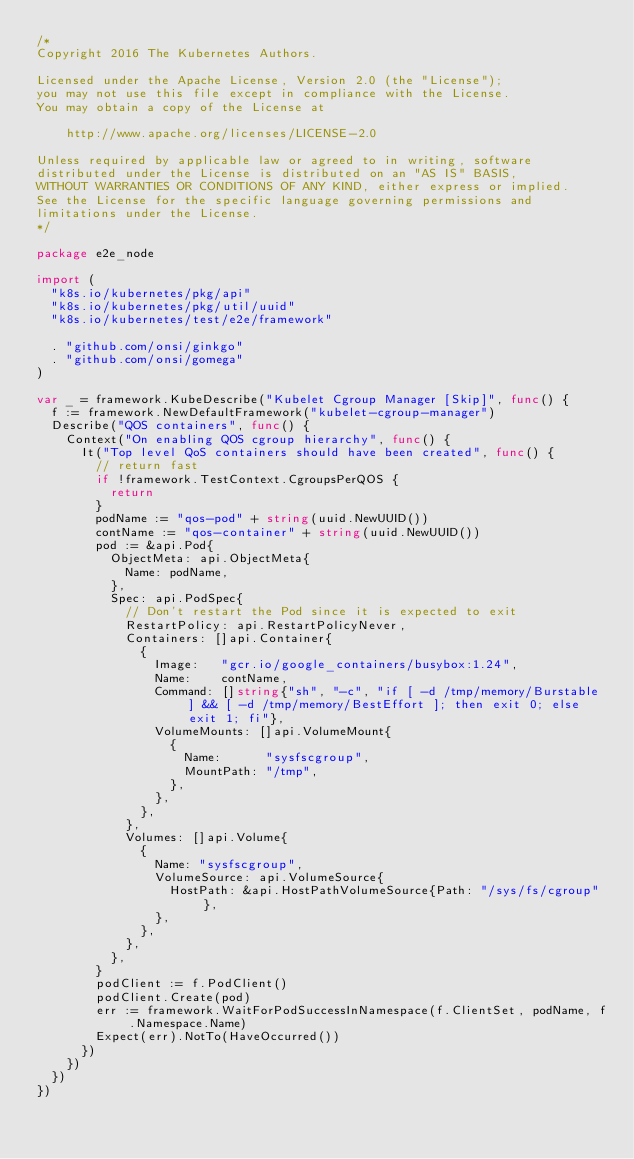<code> <loc_0><loc_0><loc_500><loc_500><_Go_>/*
Copyright 2016 The Kubernetes Authors.

Licensed under the Apache License, Version 2.0 (the "License");
you may not use this file except in compliance with the License.
You may obtain a copy of the License at

    http://www.apache.org/licenses/LICENSE-2.0

Unless required by applicable law or agreed to in writing, software
distributed under the License is distributed on an "AS IS" BASIS,
WITHOUT WARRANTIES OR CONDITIONS OF ANY KIND, either express or implied.
See the License for the specific language governing permissions and
limitations under the License.
*/

package e2e_node

import (
	"k8s.io/kubernetes/pkg/api"
	"k8s.io/kubernetes/pkg/util/uuid"
	"k8s.io/kubernetes/test/e2e/framework"

	. "github.com/onsi/ginkgo"
	. "github.com/onsi/gomega"
)

var _ = framework.KubeDescribe("Kubelet Cgroup Manager [Skip]", func() {
	f := framework.NewDefaultFramework("kubelet-cgroup-manager")
	Describe("QOS containers", func() {
		Context("On enabling QOS cgroup hierarchy", func() {
			It("Top level QoS containers should have been created", func() {
				// return fast
				if !framework.TestContext.CgroupsPerQOS {
					return
				}
				podName := "qos-pod" + string(uuid.NewUUID())
				contName := "qos-container" + string(uuid.NewUUID())
				pod := &api.Pod{
					ObjectMeta: api.ObjectMeta{
						Name: podName,
					},
					Spec: api.PodSpec{
						// Don't restart the Pod since it is expected to exit
						RestartPolicy: api.RestartPolicyNever,
						Containers: []api.Container{
							{
								Image:   "gcr.io/google_containers/busybox:1.24",
								Name:    contName,
								Command: []string{"sh", "-c", "if [ -d /tmp/memory/Burstable ] && [ -d /tmp/memory/BestEffort ]; then exit 0; else exit 1; fi"},
								VolumeMounts: []api.VolumeMount{
									{
										Name:      "sysfscgroup",
										MountPath: "/tmp",
									},
								},
							},
						},
						Volumes: []api.Volume{
							{
								Name: "sysfscgroup",
								VolumeSource: api.VolumeSource{
									HostPath: &api.HostPathVolumeSource{Path: "/sys/fs/cgroup"},
								},
							},
						},
					},
				}
				podClient := f.PodClient()
				podClient.Create(pod)
				err := framework.WaitForPodSuccessInNamespace(f.ClientSet, podName, f.Namespace.Name)
				Expect(err).NotTo(HaveOccurred())
			})
		})
	})
})
</code> 